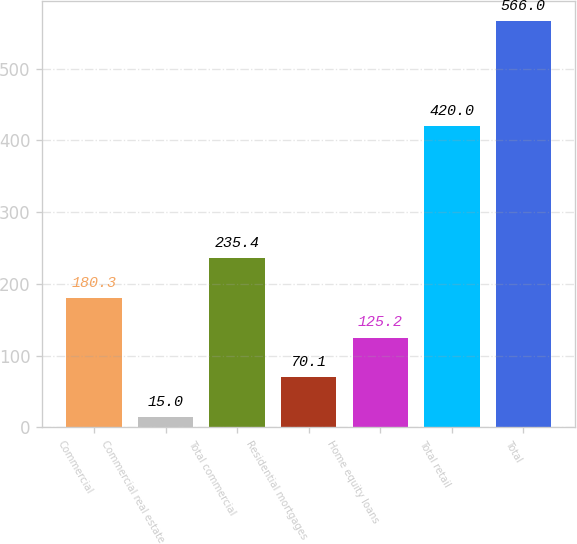Convert chart to OTSL. <chart><loc_0><loc_0><loc_500><loc_500><bar_chart><fcel>Commercial<fcel>Commercial real estate<fcel>Total commercial<fcel>Residential mortgages<fcel>Home equity loans<fcel>Total retail<fcel>Total<nl><fcel>180.3<fcel>15<fcel>235.4<fcel>70.1<fcel>125.2<fcel>420<fcel>566<nl></chart> 